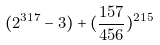<formula> <loc_0><loc_0><loc_500><loc_500>( 2 ^ { 3 1 7 } - 3 ) + ( \frac { 1 5 7 } { 4 5 6 } ) ^ { 2 1 5 }</formula> 